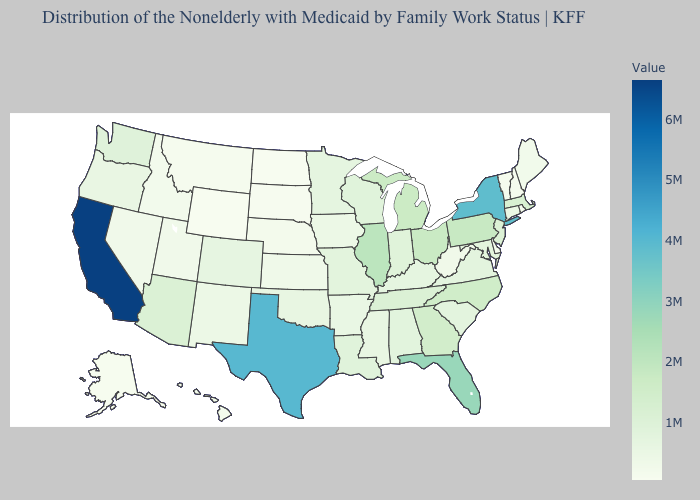Does New Hampshire have the lowest value in the Northeast?
Answer briefly. Yes. Among the states that border Georgia , does Alabama have the highest value?
Quick response, please. No. Which states have the lowest value in the South?
Answer briefly. Delaware. Which states have the lowest value in the USA?
Write a very short answer. Wyoming. Among the states that border New Jersey , which have the lowest value?
Keep it brief. Delaware. Among the states that border Minnesota , which have the highest value?
Quick response, please. Wisconsin. Among the states that border Tennessee , which have the lowest value?
Be succinct. Arkansas. 